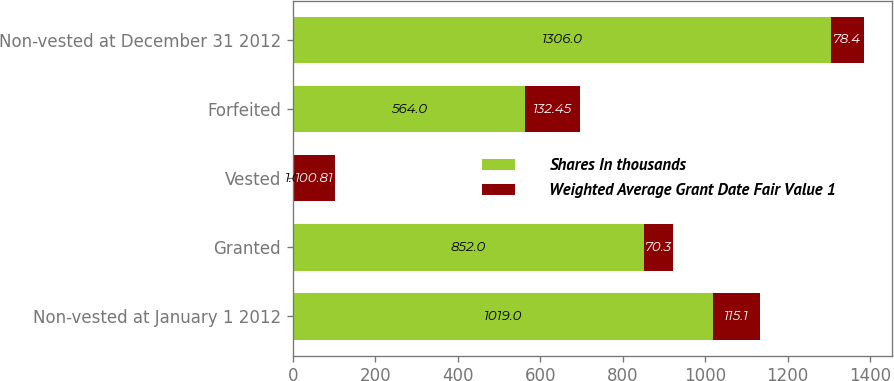Convert chart to OTSL. <chart><loc_0><loc_0><loc_500><loc_500><stacked_bar_chart><ecel><fcel>Non-vested at January 1 2012<fcel>Granted<fcel>Vested<fcel>Forfeited<fcel>Non-vested at December 31 2012<nl><fcel>Shares In thousands<fcel>1019<fcel>852<fcel>1<fcel>564<fcel>1306<nl><fcel>Weighted Average Grant Date Fair Value 1<fcel>115.1<fcel>70.3<fcel>100.81<fcel>132.45<fcel>78.4<nl></chart> 